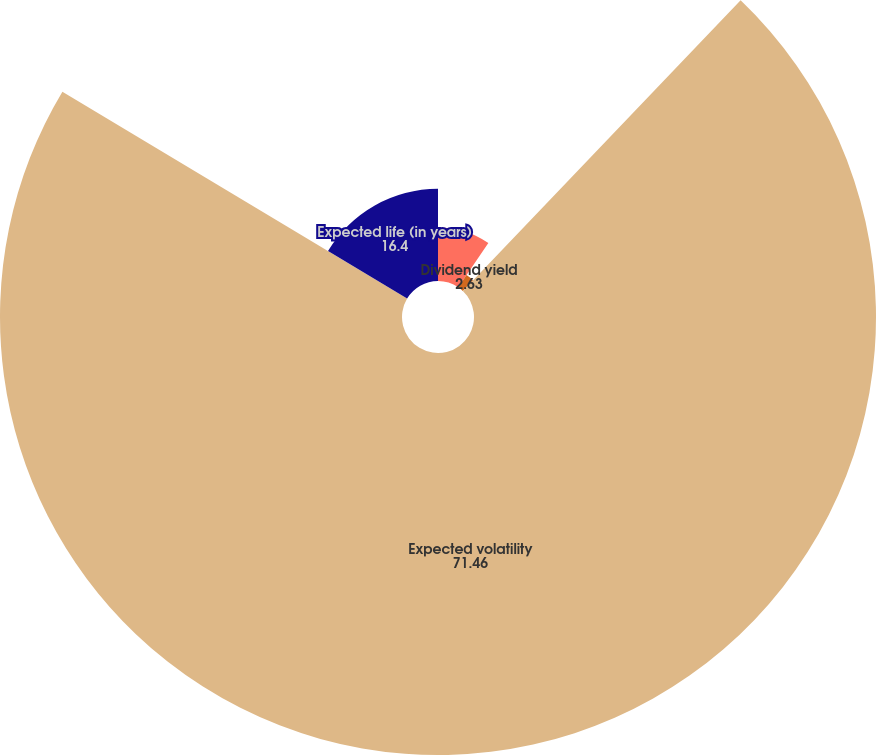Convert chart to OTSL. <chart><loc_0><loc_0><loc_500><loc_500><pie_chart><fcel>Risk-free interest rate<fcel>Dividend yield<fcel>Expected volatility<fcel>Expected life (in years)<nl><fcel>9.51%<fcel>2.63%<fcel>71.46%<fcel>16.4%<nl></chart> 